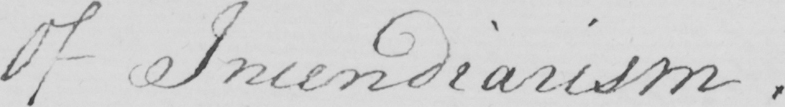What text is written in this handwritten line? Of Incendiarism . 